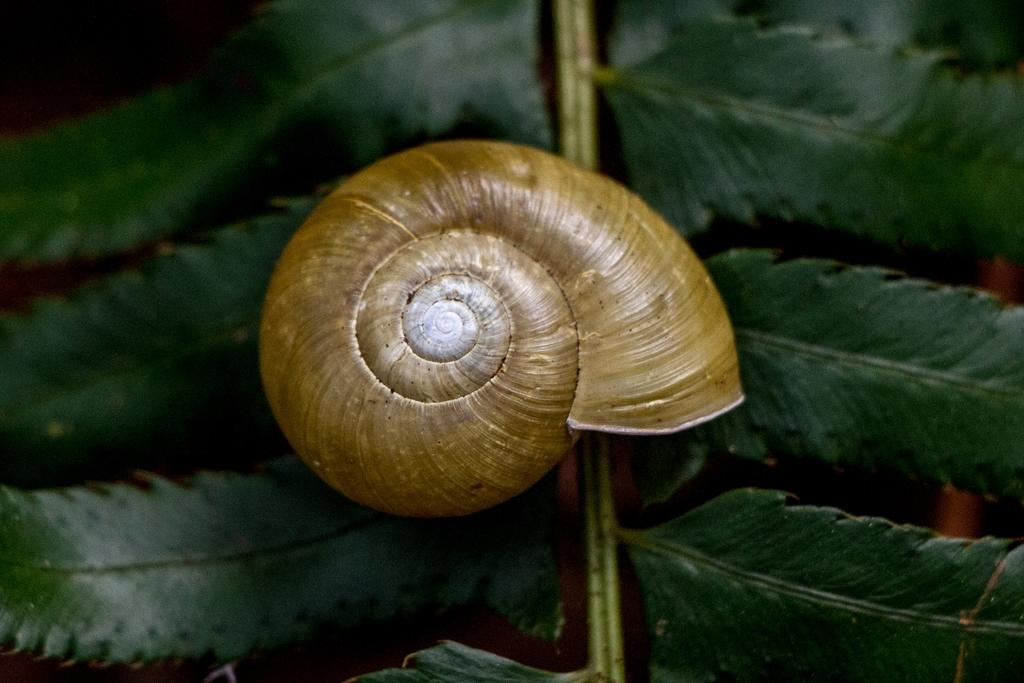What type of animal is in the image? There is a snail in the image. What other objects or elements can be seen in the image? There are leaves in the image. How are the leaves positioned or connected in the image? The leaves are attached to a stem. What type of holiday is being celebrated in the image? There is no indication of a holiday being celebrated in the image. How many snails are visible in the image? There is only one snail visible in the image. 